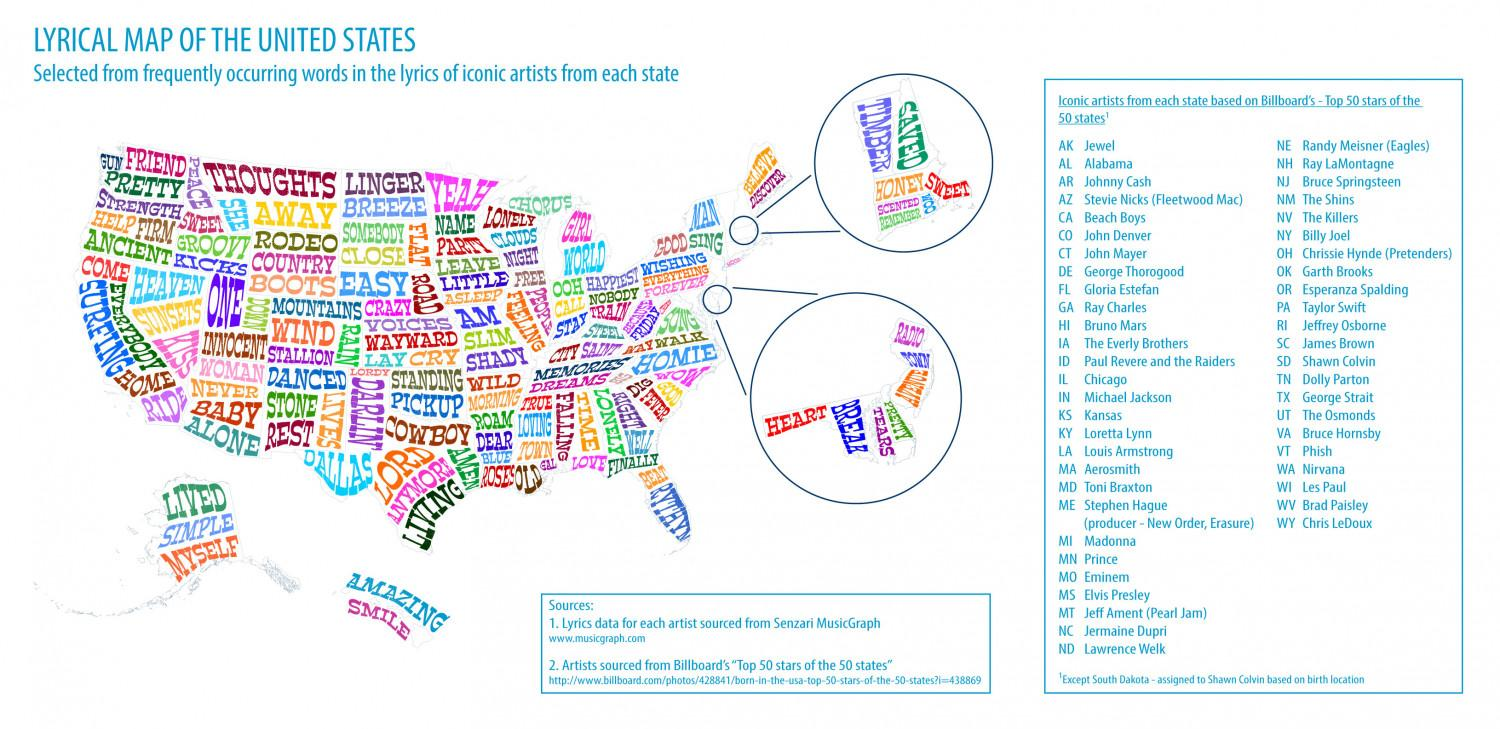Indicate a few pertinent items in this graphic. ONE is the word written in the largest letters. 